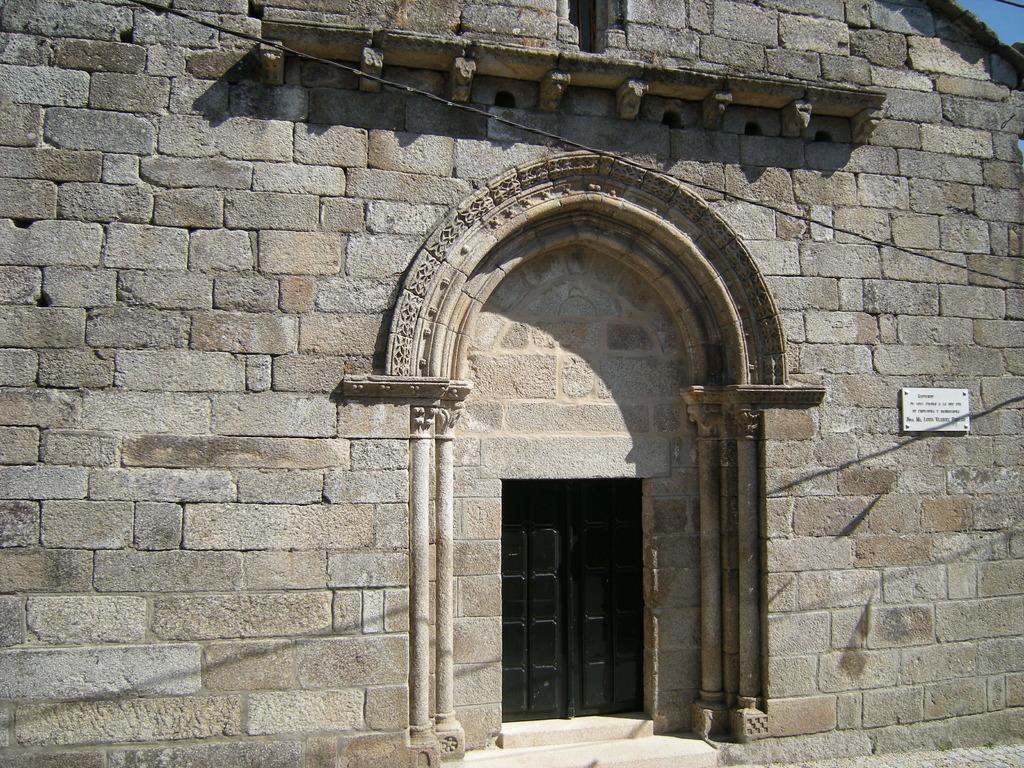Describe this image in one or two sentences. In this picture we can see a building, wire, doors, steps and on the wall we can see a name board. 